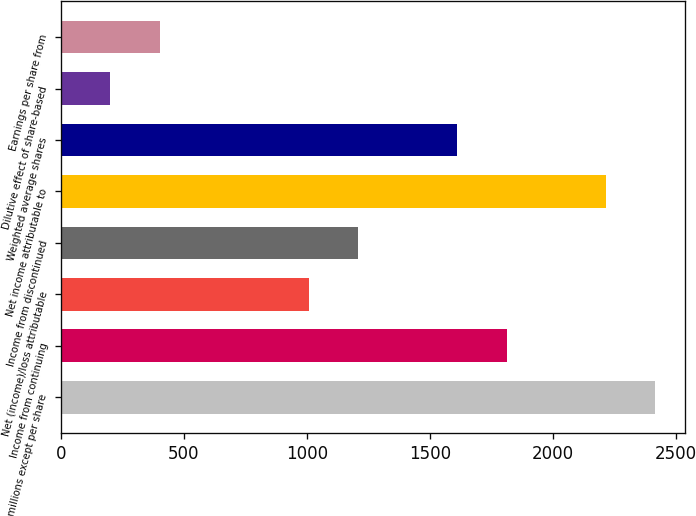Convert chart to OTSL. <chart><loc_0><loc_0><loc_500><loc_500><bar_chart><fcel>In millions except per share<fcel>Income from continuing<fcel>Net (income)/loss attributable<fcel>Income from discontinued<fcel>Net income attributable to<fcel>Weighted average shares<fcel>Dilutive effect of share-based<fcel>Earnings per share from<nl><fcel>2415.62<fcel>1811.75<fcel>1006.59<fcel>1207.88<fcel>2214.33<fcel>1610.46<fcel>201.43<fcel>402.72<nl></chart> 